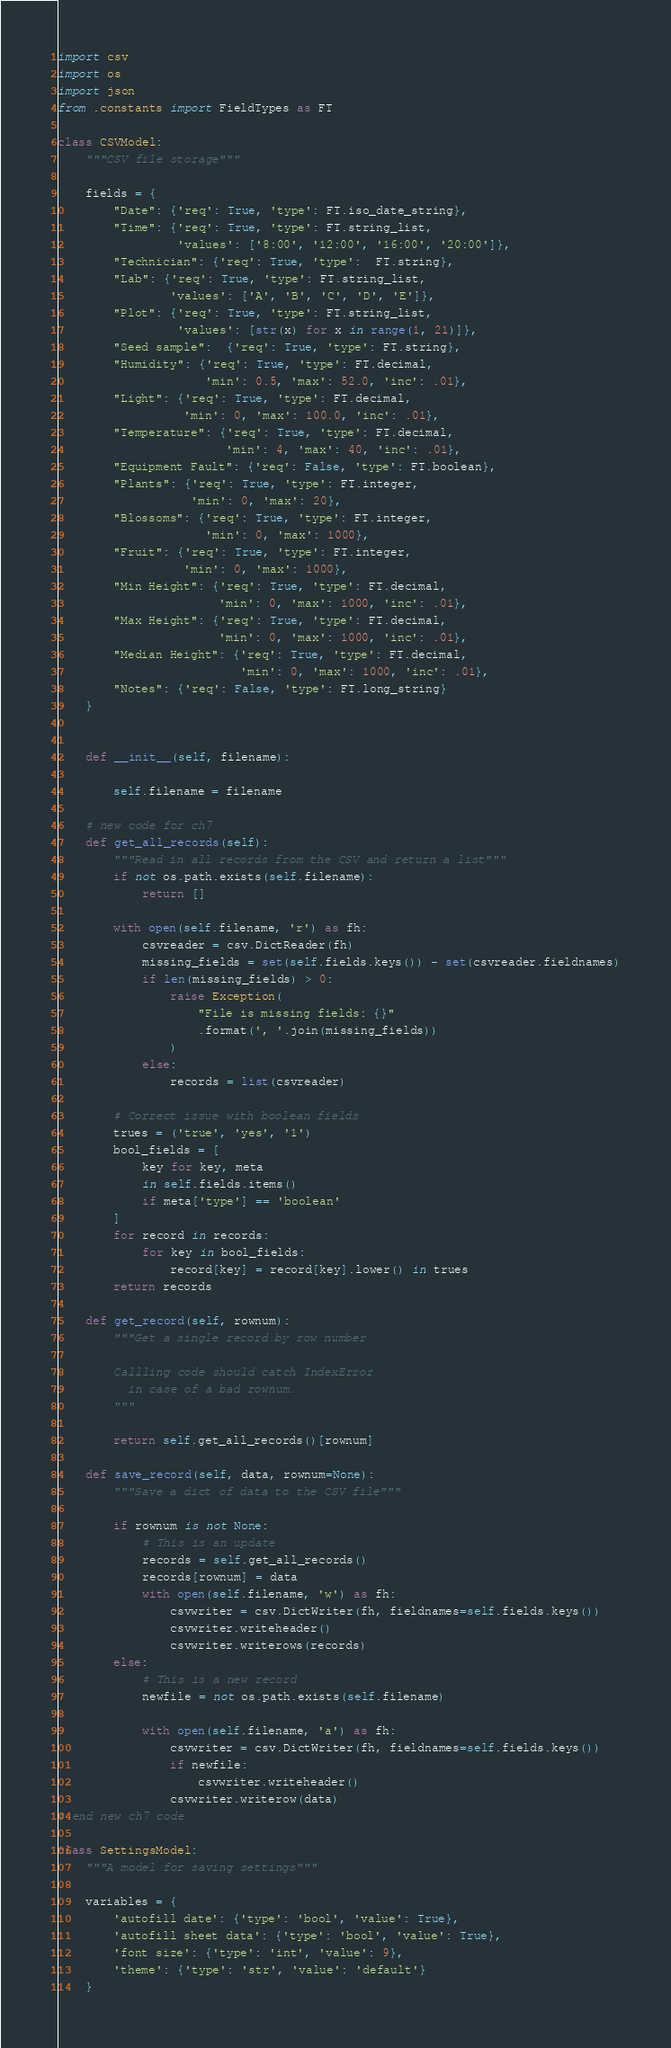<code> <loc_0><loc_0><loc_500><loc_500><_Python_>import csv
import os
import json
from .constants import FieldTypes as FT

class CSVModel:
    """CSV file storage"""

    fields = {
        "Date": {'req': True, 'type': FT.iso_date_string},
        "Time": {'req': True, 'type': FT.string_list,
                 'values': ['8:00', '12:00', '16:00', '20:00']},
        "Technician": {'req': True, 'type':  FT.string},
        "Lab": {'req': True, 'type': FT.string_list,
                'values': ['A', 'B', 'C', 'D', 'E']},
        "Plot": {'req': True, 'type': FT.string_list,
                 'values': [str(x) for x in range(1, 21)]},
        "Seed sample":  {'req': True, 'type': FT.string},
        "Humidity": {'req': True, 'type': FT.decimal,
                     'min': 0.5, 'max': 52.0, 'inc': .01},
        "Light": {'req': True, 'type': FT.decimal,
                  'min': 0, 'max': 100.0, 'inc': .01},
        "Temperature": {'req': True, 'type': FT.decimal,
                        'min': 4, 'max': 40, 'inc': .01},
        "Equipment Fault": {'req': False, 'type': FT.boolean},
        "Plants": {'req': True, 'type': FT.integer,
                   'min': 0, 'max': 20},
        "Blossoms": {'req': True, 'type': FT.integer,
                     'min': 0, 'max': 1000},
        "Fruit": {'req': True, 'type': FT.integer,
                  'min': 0, 'max': 1000},
        "Min Height": {'req': True, 'type': FT.decimal,
                       'min': 0, 'max': 1000, 'inc': .01},
        "Max Height": {'req': True, 'type': FT.decimal,
                       'min': 0, 'max': 1000, 'inc': .01},
        "Median Height": {'req': True, 'type': FT.decimal,
                          'min': 0, 'max': 1000, 'inc': .01},
        "Notes": {'req': False, 'type': FT.long_string}
    }


    def __init__(self, filename):

        self.filename = filename

    # new code for ch7
    def get_all_records(self):
        """Read in all records from the CSV and return a list"""
        if not os.path.exists(self.filename):
            return []

        with open(self.filename, 'r') as fh:
            csvreader = csv.DictReader(fh)
            missing_fields = set(self.fields.keys()) - set(csvreader.fieldnames)
            if len(missing_fields) > 0:
                raise Exception(
                    "File is missing fields: {}"
                    .format(', '.join(missing_fields))
                )
            else:
                records = list(csvreader)

        # Correct issue with boolean fields
        trues = ('true', 'yes', '1')
        bool_fields = [
            key for key, meta
            in self.fields.items()
            if meta['type'] == 'boolean'
        ]
        for record in records:
            for key in bool_fields:
                record[key] = record[key].lower() in trues
        return records

    def get_record(self, rownum):
        """Get a single record by row number

        Callling code should catch IndexError
          in case of a bad rownum.
        """

        return self.get_all_records()[rownum]

    def save_record(self, data, rownum=None):
        """Save a dict of data to the CSV file"""

        if rownum is not None:
            # This is an update
            records = self.get_all_records()
            records[rownum] = data
            with open(self.filename, 'w') as fh:
                csvwriter = csv.DictWriter(fh, fieldnames=self.fields.keys())
                csvwriter.writeheader()
                csvwriter.writerows(records)
        else:
            # This is a new record
            newfile = not os.path.exists(self.filename)

            with open(self.filename, 'a') as fh:
                csvwriter = csv.DictWriter(fh, fieldnames=self.fields.keys())
                if newfile:
                    csvwriter.writeheader()
                csvwriter.writerow(data)
# end new ch7 code

class SettingsModel:
    """A model for saving settings"""

    variables = {
        'autofill date': {'type': 'bool', 'value': True},
        'autofill sheet data': {'type': 'bool', 'value': True},
        'font size': {'type': 'int', 'value': 9},
        'theme': {'type': 'str', 'value': 'default'}
    }
</code> 